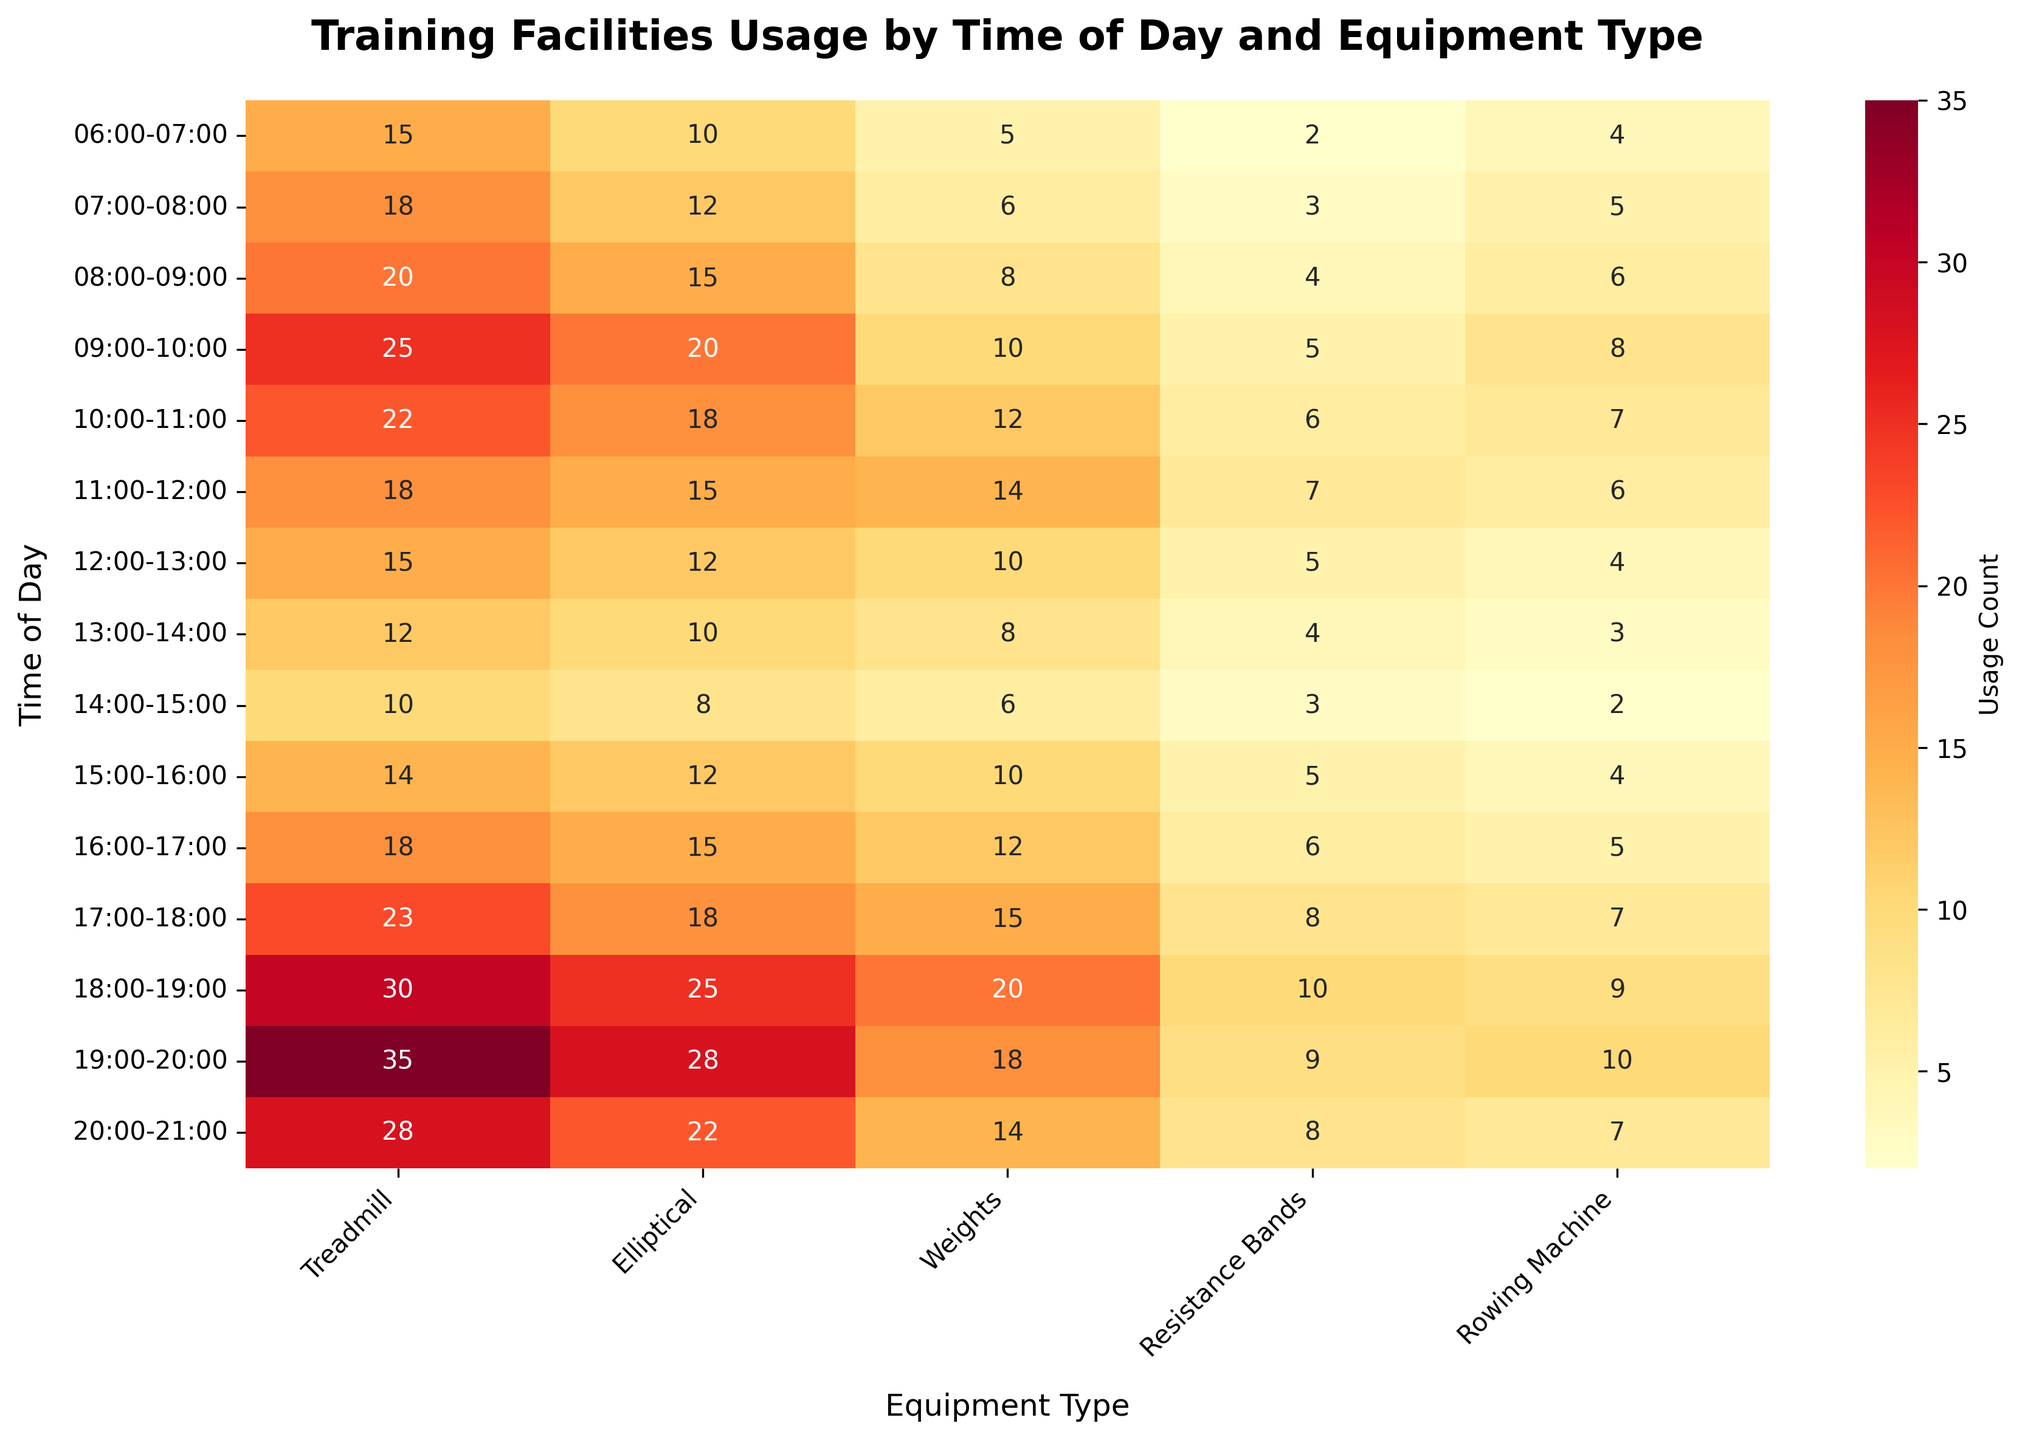What is the title of the heatmap? The title is a text at the top of the heatmap that usually summarizes the content of the chart. Here, it indicates what the heatmap represents.
Answer: Training Facilities Usage by Time of Day and Equipment Type Which equipment has the highest usage in the 18:00-19:00 time slot? Look at the values along the 18:00-19:00 row. Identify the equipment with the highest numerical value.
Answer: Treadmill During which time period is the usage of Resistance Bands the highest? Check all the cells in the Resistance Bands column and find the maximum value. Note the corresponding time period on the left.
Answer: 18:00-19:00 What is the difference in treadmill usage between 06:00-07:00 and 20:00-21:00? Look at the values in the Treadmill column under the given time periods and compute the difference (absolute value) between them.
Answer: 13 Which time slot has the lowest usage of the Elliptical machine? Review the values in the Elliptical column and find the minimum value. Identify the corresponding time slot on the left.
Answer: 14:00-15:00 What's the average usage of Weights between 06:00-07:00 and 12:00-13:00? Add up the values for Weights from 06:00-07:00 to 12:00-13:00 and divide by the number of time slots (7). \( (5 + 6 + 8 + 10 + 12 + 14 + 10) / 7 \)
Answer: 9.29 How does the usage of the Rowing Machine at 09:00-10:00 compare to its usage at 15:00-16:00? Find the values for the Rowing Machine at the specified times and make a comparison. Check which value is higher.
Answer: Higher at 09:00-10:00 Which piece of equipment is consistently used the most throughout the day? By visually scanning each column, identify which equipment type has the highest values most often compared to others.
Answer: Treadmill Across which time period is the usage of the gym facilities the lowest overall? Add up the total usage (sum of all equipment) for each time period and identify the period with the lowest total value.
Answer: 14:00-15:00 What is the most noticeable trend in the evening hours (17:00-21:00) compared to the morning hours (06:00-10:00)? Compare the overall pattern of values between the given time periods. Note if there's a general increase or consistent change in any direction.
Answer: Increase in overall usage 